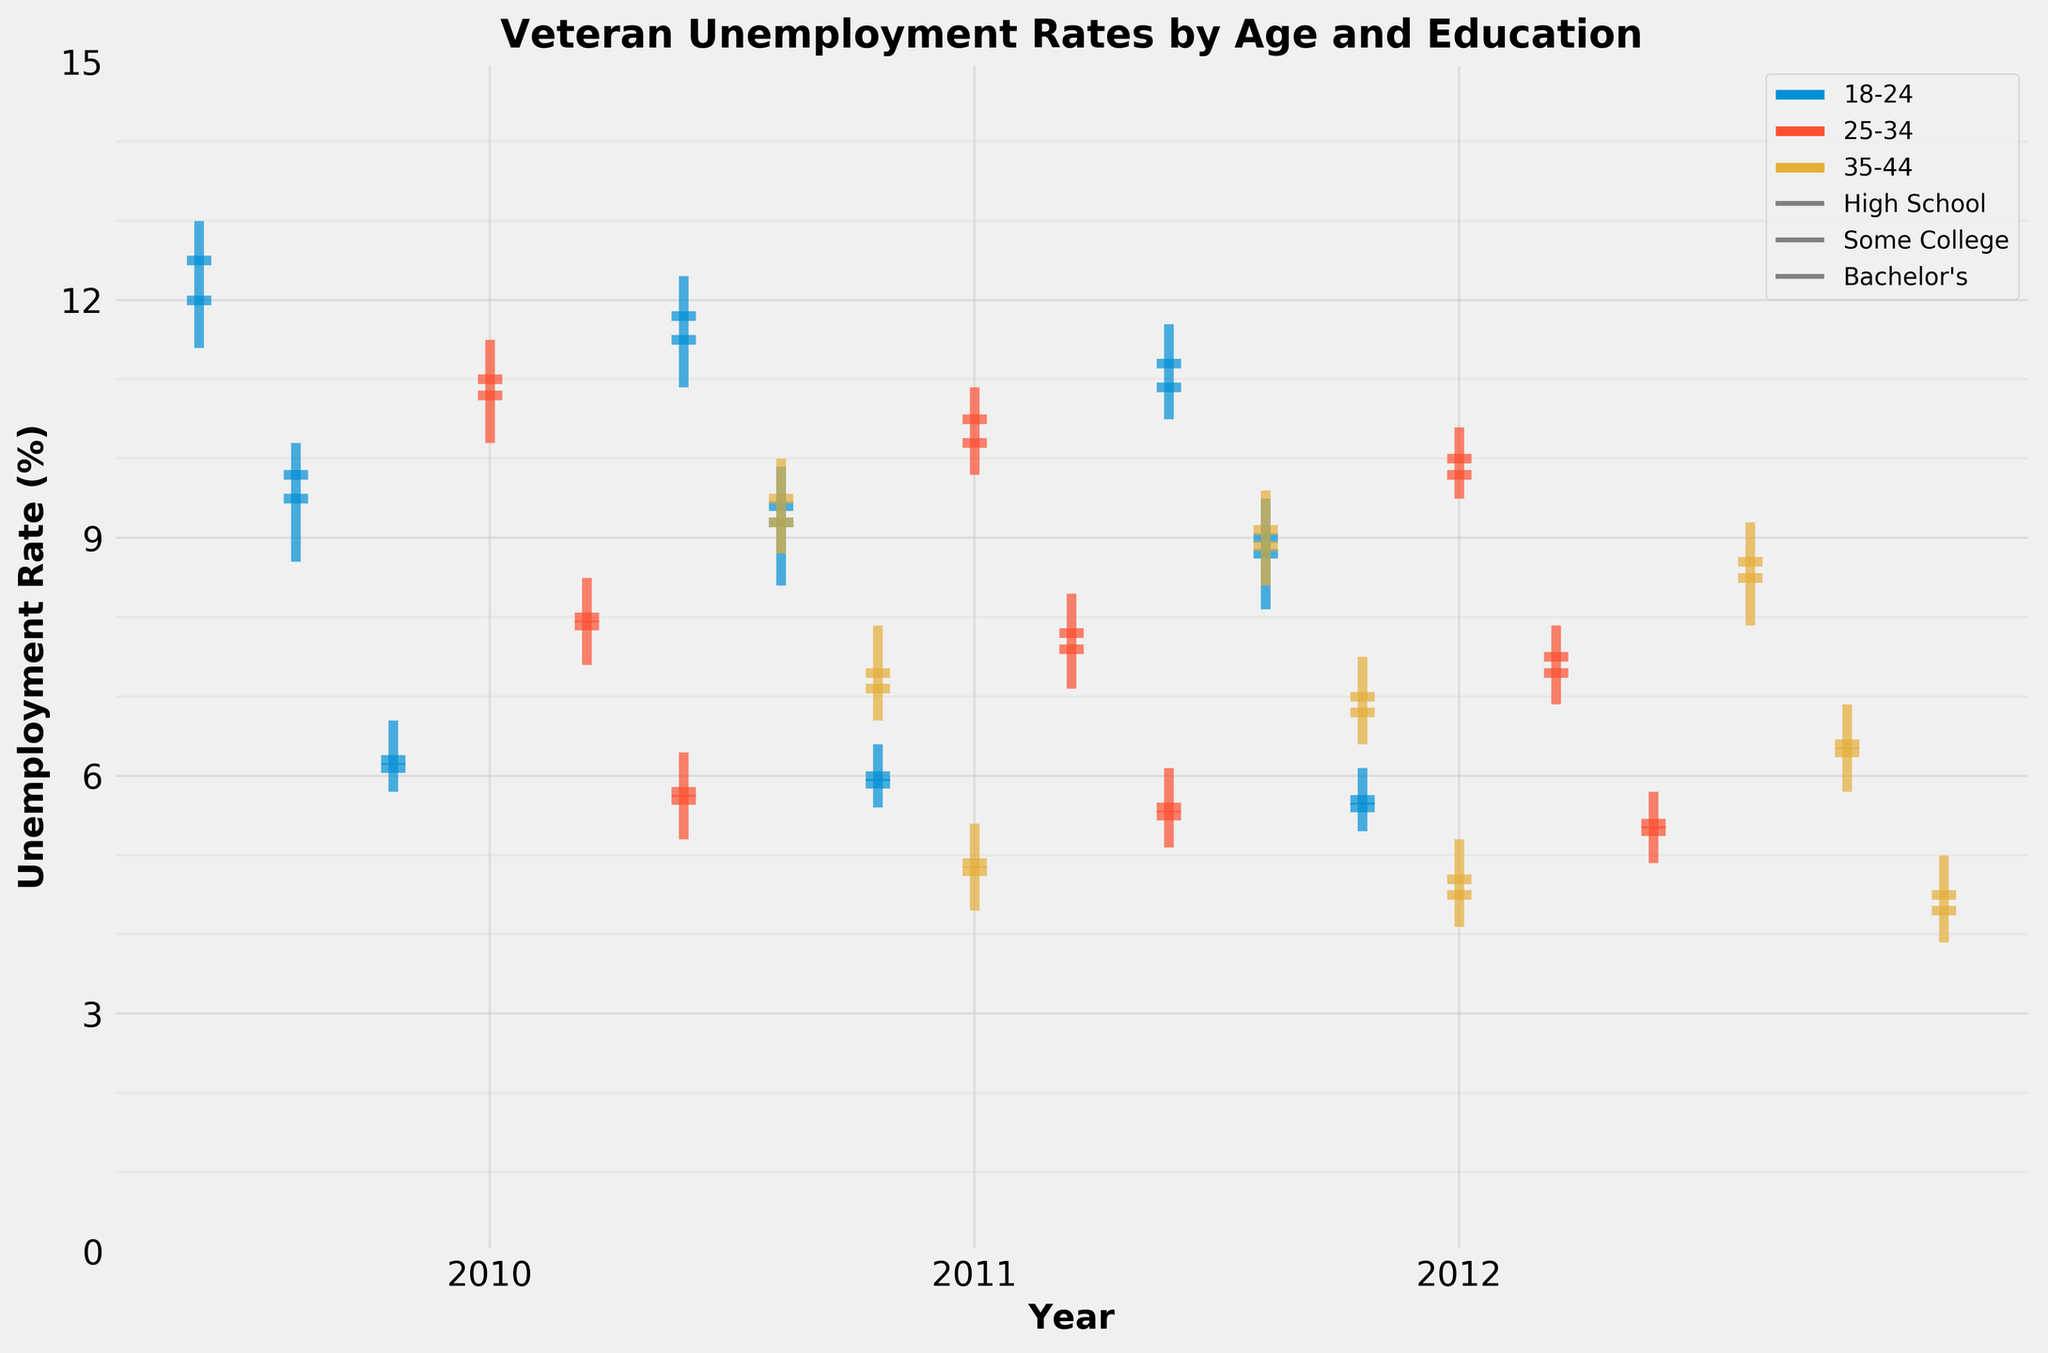What is the title of the figure? The title of the figure is at the top and can be read directly. The title is "Veteran Unemployment Rates by Age and Education".
Answer: Veteran Unemployment Rates by Age and Education What do the x-axis labels represent? The x-axis labels represent the years for which the unemployment data was collected. They are arranged chronologically from left to right.
Answer: Years What does the color of the lines represent in the plot? The color of the lines corresponds to different age groups of veterans, as indicated by the legend on the right side of the plot. Each age group has a distinct color.
Answer: Different age groups Which age group and education level had the highest unemployment rate in 2010? To find the highest unemployment rate, look for the highest point on the candlestick plot for the year 2010. The "High" value is represented by the top of the vertical line. The 18-24 age group with a High School education level had the highest rate.
Answer: 18-24 age group with High School education How did the unemployment rate change for veterans aged 18-24 with a Bachelor's degree from 2010 to 2012? Compare the candlesticks over the three years. For veterans aged 18-24 with a Bachelor's degree, the "Close" values for 2010, 2011, and 2012 are 6.1%, 5.9%, and 5.6%, respectively. The rate decreased over time.
Answer: Decreased Which education level consistently had the lowest unemployment rates across all age groups from 2010 to 2012? Inspect the candlesticks for each education level across all age groups and years. The "Low" values can help determine this. The Bachelor's degree consistently shows the lowest unemployment rates across all age groups.
Answer: Bachelor's degree In 2011, which age group had the smallest range of unemployment rates (difference between High and Low) within the High School education level? Calculate the range (High - Low) for each age group within the High School education level for 2011. The ranges are: 18-24 (1.4), 25-34 (1.1), 35-44 (1.2). The 25-34 age group had the smallest range.
Answer: 25-34 age group Compare the highest unemployment rates for veterans with some college education between 2010 and 2012 across all age groups. Look at the "High" values for some college education across all age groups from 2010 to 2012. In 2010: 18-24 (10.2%), 25-34 (8.5%), 35-44 (7.9%). In 2012: 18-24 (9.5%), 25-34 (7.9%), 35-44 (6.9%). The highest rates for each year are 10.2% and 9.5% respectively.
Answer: 10.2% in 2010 and 9.5% in 2012 What was the unemployment rate trend for veterans aged 35-44 with some college education from 2010 to 2012? To identify trends, compare the "Close" values for the specified group. The "Close" values for 2010, 2011, and 2012 are 7.1%, 6.8%, and 6.3%, respectively. The rate showed a decreasing trend.
Answer: Decreasing What is the average "Close" unemployment rate for the 25-34 age group with a Bachelor's degree from 2010 to 2012? Sum the "Close" values for the three years (5.7, 5.5, 5.3) and divide by 3. Calculation: (5.7 + 5.5 + 5.3) / 3 = 5.5.
Answer: 5.5 